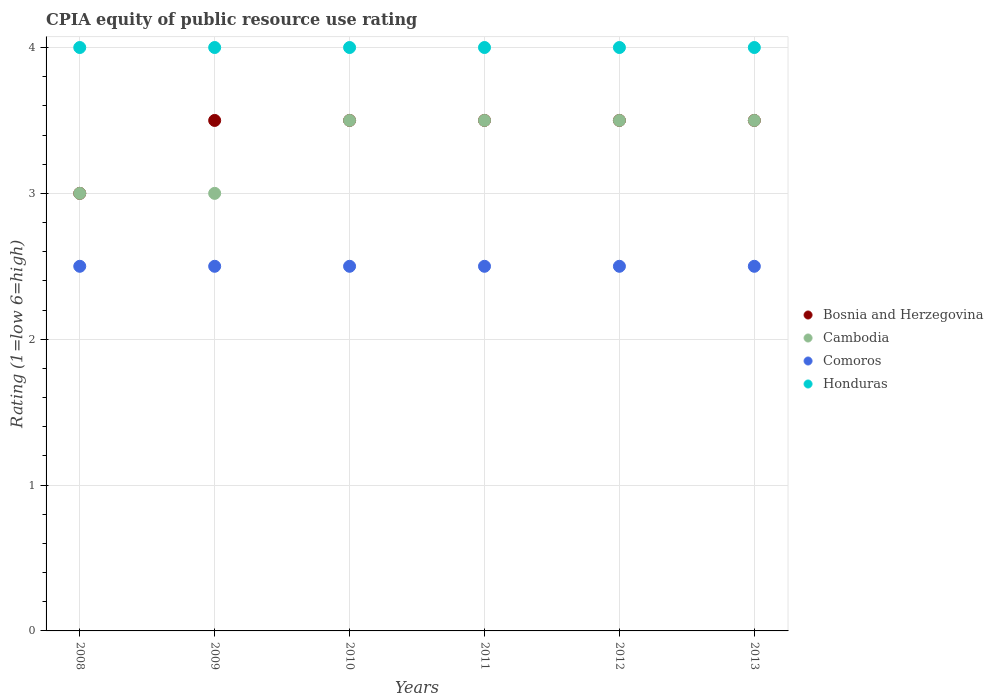Is the number of dotlines equal to the number of legend labels?
Your answer should be compact. Yes. What is the CPIA rating in Comoros in 2009?
Offer a terse response. 2.5. Across all years, what is the minimum CPIA rating in Cambodia?
Provide a succinct answer. 3. In which year was the CPIA rating in Comoros maximum?
Your answer should be compact. 2008. In which year was the CPIA rating in Bosnia and Herzegovina minimum?
Keep it short and to the point. 2008. What is the average CPIA rating in Bosnia and Herzegovina per year?
Give a very brief answer. 3.42. What is the ratio of the CPIA rating in Honduras in 2009 to that in 2013?
Provide a succinct answer. 1. Is the CPIA rating in Honduras in 2011 less than that in 2012?
Offer a terse response. No. Is the difference between the CPIA rating in Comoros in 2008 and 2009 greater than the difference between the CPIA rating in Cambodia in 2008 and 2009?
Your answer should be very brief. No. What is the difference between the highest and the second highest CPIA rating in Cambodia?
Provide a short and direct response. 0. In how many years, is the CPIA rating in Comoros greater than the average CPIA rating in Comoros taken over all years?
Give a very brief answer. 0. Is the sum of the CPIA rating in Cambodia in 2008 and 2011 greater than the maximum CPIA rating in Honduras across all years?
Provide a short and direct response. Yes. Is it the case that in every year, the sum of the CPIA rating in Bosnia and Herzegovina and CPIA rating in Comoros  is greater than the CPIA rating in Cambodia?
Make the answer very short. Yes. Is the CPIA rating in Bosnia and Herzegovina strictly greater than the CPIA rating in Comoros over the years?
Your answer should be very brief. Yes. How many years are there in the graph?
Keep it short and to the point. 6. Does the graph contain any zero values?
Offer a terse response. No. Does the graph contain grids?
Give a very brief answer. Yes. How many legend labels are there?
Ensure brevity in your answer.  4. How are the legend labels stacked?
Your answer should be very brief. Vertical. What is the title of the graph?
Ensure brevity in your answer.  CPIA equity of public resource use rating. What is the label or title of the X-axis?
Your answer should be very brief. Years. What is the label or title of the Y-axis?
Offer a very short reply. Rating (1=low 6=high). What is the Rating (1=low 6=high) in Bosnia and Herzegovina in 2008?
Provide a short and direct response. 3. What is the Rating (1=low 6=high) of Bosnia and Herzegovina in 2009?
Your response must be concise. 3.5. What is the Rating (1=low 6=high) in Cambodia in 2009?
Provide a short and direct response. 3. What is the Rating (1=low 6=high) in Comoros in 2009?
Your answer should be compact. 2.5. What is the Rating (1=low 6=high) in Honduras in 2009?
Your answer should be compact. 4. What is the Rating (1=low 6=high) in Bosnia and Herzegovina in 2010?
Provide a short and direct response. 3.5. What is the Rating (1=low 6=high) in Cambodia in 2010?
Keep it short and to the point. 3.5. What is the Rating (1=low 6=high) in Comoros in 2010?
Offer a very short reply. 2.5. What is the Rating (1=low 6=high) in Honduras in 2010?
Make the answer very short. 4. What is the Rating (1=low 6=high) of Bosnia and Herzegovina in 2011?
Provide a short and direct response. 3.5. What is the Rating (1=low 6=high) of Comoros in 2012?
Your answer should be very brief. 2.5. What is the Rating (1=low 6=high) of Cambodia in 2013?
Provide a short and direct response. 3.5. What is the Rating (1=low 6=high) of Comoros in 2013?
Keep it short and to the point. 2.5. What is the Rating (1=low 6=high) of Honduras in 2013?
Your answer should be compact. 4. Across all years, what is the maximum Rating (1=low 6=high) in Bosnia and Herzegovina?
Give a very brief answer. 3.5. Across all years, what is the maximum Rating (1=low 6=high) of Honduras?
Keep it short and to the point. 4. Across all years, what is the minimum Rating (1=low 6=high) in Bosnia and Herzegovina?
Offer a terse response. 3. Across all years, what is the minimum Rating (1=low 6=high) in Comoros?
Offer a very short reply. 2.5. Across all years, what is the minimum Rating (1=low 6=high) in Honduras?
Make the answer very short. 4. What is the total Rating (1=low 6=high) of Honduras in the graph?
Provide a short and direct response. 24. What is the difference between the Rating (1=low 6=high) in Bosnia and Herzegovina in 2008 and that in 2009?
Give a very brief answer. -0.5. What is the difference between the Rating (1=low 6=high) in Comoros in 2008 and that in 2009?
Keep it short and to the point. 0. What is the difference between the Rating (1=low 6=high) of Honduras in 2008 and that in 2009?
Your answer should be very brief. 0. What is the difference between the Rating (1=low 6=high) in Honduras in 2008 and that in 2010?
Your answer should be compact. 0. What is the difference between the Rating (1=low 6=high) in Honduras in 2008 and that in 2011?
Offer a very short reply. 0. What is the difference between the Rating (1=low 6=high) of Bosnia and Herzegovina in 2008 and that in 2012?
Your answer should be very brief. -0.5. What is the difference between the Rating (1=low 6=high) of Honduras in 2008 and that in 2012?
Your response must be concise. 0. What is the difference between the Rating (1=low 6=high) of Bosnia and Herzegovina in 2008 and that in 2013?
Give a very brief answer. -0.5. What is the difference between the Rating (1=low 6=high) in Cambodia in 2008 and that in 2013?
Provide a succinct answer. -0.5. What is the difference between the Rating (1=low 6=high) of Bosnia and Herzegovina in 2009 and that in 2010?
Keep it short and to the point. 0. What is the difference between the Rating (1=low 6=high) in Honduras in 2009 and that in 2010?
Offer a terse response. 0. What is the difference between the Rating (1=low 6=high) of Cambodia in 2009 and that in 2011?
Your answer should be very brief. -0.5. What is the difference between the Rating (1=low 6=high) in Bosnia and Herzegovina in 2009 and that in 2012?
Offer a terse response. 0. What is the difference between the Rating (1=low 6=high) in Bosnia and Herzegovina in 2009 and that in 2013?
Ensure brevity in your answer.  0. What is the difference between the Rating (1=low 6=high) in Cambodia in 2009 and that in 2013?
Provide a short and direct response. -0.5. What is the difference between the Rating (1=low 6=high) in Bosnia and Herzegovina in 2010 and that in 2011?
Give a very brief answer. 0. What is the difference between the Rating (1=low 6=high) of Honduras in 2010 and that in 2011?
Give a very brief answer. 0. What is the difference between the Rating (1=low 6=high) in Bosnia and Herzegovina in 2010 and that in 2012?
Offer a terse response. 0. What is the difference between the Rating (1=low 6=high) in Cambodia in 2010 and that in 2012?
Provide a short and direct response. 0. What is the difference between the Rating (1=low 6=high) of Bosnia and Herzegovina in 2010 and that in 2013?
Offer a terse response. 0. What is the difference between the Rating (1=low 6=high) in Comoros in 2010 and that in 2013?
Your response must be concise. 0. What is the difference between the Rating (1=low 6=high) of Honduras in 2010 and that in 2013?
Offer a terse response. 0. What is the difference between the Rating (1=low 6=high) of Bosnia and Herzegovina in 2011 and that in 2012?
Ensure brevity in your answer.  0. What is the difference between the Rating (1=low 6=high) in Honduras in 2011 and that in 2012?
Your answer should be compact. 0. What is the difference between the Rating (1=low 6=high) in Bosnia and Herzegovina in 2011 and that in 2013?
Your response must be concise. 0. What is the difference between the Rating (1=low 6=high) of Honduras in 2011 and that in 2013?
Give a very brief answer. 0. What is the difference between the Rating (1=low 6=high) of Comoros in 2012 and that in 2013?
Keep it short and to the point. 0. What is the difference between the Rating (1=low 6=high) of Bosnia and Herzegovina in 2008 and the Rating (1=low 6=high) of Cambodia in 2009?
Your response must be concise. 0. What is the difference between the Rating (1=low 6=high) of Bosnia and Herzegovina in 2008 and the Rating (1=low 6=high) of Comoros in 2009?
Your response must be concise. 0.5. What is the difference between the Rating (1=low 6=high) in Bosnia and Herzegovina in 2008 and the Rating (1=low 6=high) in Honduras in 2009?
Your response must be concise. -1. What is the difference between the Rating (1=low 6=high) in Comoros in 2008 and the Rating (1=low 6=high) in Honduras in 2009?
Offer a terse response. -1.5. What is the difference between the Rating (1=low 6=high) of Bosnia and Herzegovina in 2008 and the Rating (1=low 6=high) of Comoros in 2010?
Ensure brevity in your answer.  0.5. What is the difference between the Rating (1=low 6=high) of Bosnia and Herzegovina in 2008 and the Rating (1=low 6=high) of Honduras in 2010?
Ensure brevity in your answer.  -1. What is the difference between the Rating (1=low 6=high) in Cambodia in 2008 and the Rating (1=low 6=high) in Comoros in 2010?
Keep it short and to the point. 0.5. What is the difference between the Rating (1=low 6=high) in Cambodia in 2008 and the Rating (1=low 6=high) in Honduras in 2010?
Offer a very short reply. -1. What is the difference between the Rating (1=low 6=high) in Comoros in 2008 and the Rating (1=low 6=high) in Honduras in 2010?
Offer a terse response. -1.5. What is the difference between the Rating (1=low 6=high) in Bosnia and Herzegovina in 2008 and the Rating (1=low 6=high) in Honduras in 2011?
Your answer should be very brief. -1. What is the difference between the Rating (1=low 6=high) of Cambodia in 2008 and the Rating (1=low 6=high) of Honduras in 2011?
Your response must be concise. -1. What is the difference between the Rating (1=low 6=high) in Comoros in 2008 and the Rating (1=low 6=high) in Honduras in 2011?
Ensure brevity in your answer.  -1.5. What is the difference between the Rating (1=low 6=high) of Bosnia and Herzegovina in 2008 and the Rating (1=low 6=high) of Cambodia in 2012?
Your answer should be compact. -0.5. What is the difference between the Rating (1=low 6=high) of Cambodia in 2008 and the Rating (1=low 6=high) of Honduras in 2012?
Offer a very short reply. -1. What is the difference between the Rating (1=low 6=high) in Comoros in 2008 and the Rating (1=low 6=high) in Honduras in 2012?
Offer a very short reply. -1.5. What is the difference between the Rating (1=low 6=high) of Bosnia and Herzegovina in 2008 and the Rating (1=low 6=high) of Comoros in 2013?
Make the answer very short. 0.5. What is the difference between the Rating (1=low 6=high) in Bosnia and Herzegovina in 2008 and the Rating (1=low 6=high) in Honduras in 2013?
Give a very brief answer. -1. What is the difference between the Rating (1=low 6=high) in Cambodia in 2008 and the Rating (1=low 6=high) in Honduras in 2013?
Your response must be concise. -1. What is the difference between the Rating (1=low 6=high) in Bosnia and Herzegovina in 2009 and the Rating (1=low 6=high) in Cambodia in 2010?
Your answer should be very brief. 0. What is the difference between the Rating (1=low 6=high) in Bosnia and Herzegovina in 2009 and the Rating (1=low 6=high) in Honduras in 2010?
Give a very brief answer. -0.5. What is the difference between the Rating (1=low 6=high) in Cambodia in 2009 and the Rating (1=low 6=high) in Comoros in 2010?
Offer a terse response. 0.5. What is the difference between the Rating (1=low 6=high) in Cambodia in 2009 and the Rating (1=low 6=high) in Honduras in 2010?
Ensure brevity in your answer.  -1. What is the difference between the Rating (1=low 6=high) in Comoros in 2009 and the Rating (1=low 6=high) in Honduras in 2010?
Give a very brief answer. -1.5. What is the difference between the Rating (1=low 6=high) in Bosnia and Herzegovina in 2009 and the Rating (1=low 6=high) in Cambodia in 2012?
Your response must be concise. 0. What is the difference between the Rating (1=low 6=high) in Bosnia and Herzegovina in 2009 and the Rating (1=low 6=high) in Honduras in 2012?
Your response must be concise. -0.5. What is the difference between the Rating (1=low 6=high) of Cambodia in 2009 and the Rating (1=low 6=high) of Honduras in 2012?
Your response must be concise. -1. What is the difference between the Rating (1=low 6=high) of Cambodia in 2009 and the Rating (1=low 6=high) of Honduras in 2013?
Provide a short and direct response. -1. What is the difference between the Rating (1=low 6=high) of Comoros in 2009 and the Rating (1=low 6=high) of Honduras in 2013?
Offer a terse response. -1.5. What is the difference between the Rating (1=low 6=high) in Cambodia in 2010 and the Rating (1=low 6=high) in Comoros in 2011?
Your response must be concise. 1. What is the difference between the Rating (1=low 6=high) in Cambodia in 2010 and the Rating (1=low 6=high) in Honduras in 2011?
Give a very brief answer. -0.5. What is the difference between the Rating (1=low 6=high) of Bosnia and Herzegovina in 2010 and the Rating (1=low 6=high) of Cambodia in 2012?
Provide a short and direct response. 0. What is the difference between the Rating (1=low 6=high) in Bosnia and Herzegovina in 2010 and the Rating (1=low 6=high) in Comoros in 2012?
Ensure brevity in your answer.  1. What is the difference between the Rating (1=low 6=high) in Cambodia in 2010 and the Rating (1=low 6=high) in Comoros in 2012?
Keep it short and to the point. 1. What is the difference between the Rating (1=low 6=high) of Comoros in 2010 and the Rating (1=low 6=high) of Honduras in 2012?
Keep it short and to the point. -1.5. What is the difference between the Rating (1=low 6=high) of Bosnia and Herzegovina in 2010 and the Rating (1=low 6=high) of Comoros in 2013?
Keep it short and to the point. 1. What is the difference between the Rating (1=low 6=high) of Bosnia and Herzegovina in 2010 and the Rating (1=low 6=high) of Honduras in 2013?
Provide a succinct answer. -0.5. What is the difference between the Rating (1=low 6=high) of Cambodia in 2011 and the Rating (1=low 6=high) of Comoros in 2012?
Your response must be concise. 1. What is the difference between the Rating (1=low 6=high) of Cambodia in 2011 and the Rating (1=low 6=high) of Honduras in 2012?
Your answer should be compact. -0.5. What is the difference between the Rating (1=low 6=high) of Bosnia and Herzegovina in 2011 and the Rating (1=low 6=high) of Cambodia in 2013?
Give a very brief answer. 0. What is the difference between the Rating (1=low 6=high) in Bosnia and Herzegovina in 2011 and the Rating (1=low 6=high) in Comoros in 2013?
Make the answer very short. 1. What is the difference between the Rating (1=low 6=high) of Bosnia and Herzegovina in 2011 and the Rating (1=low 6=high) of Honduras in 2013?
Make the answer very short. -0.5. What is the difference between the Rating (1=low 6=high) in Bosnia and Herzegovina in 2012 and the Rating (1=low 6=high) in Comoros in 2013?
Keep it short and to the point. 1. What is the difference between the Rating (1=low 6=high) in Cambodia in 2012 and the Rating (1=low 6=high) in Honduras in 2013?
Ensure brevity in your answer.  -0.5. What is the average Rating (1=low 6=high) in Bosnia and Herzegovina per year?
Ensure brevity in your answer.  3.42. What is the average Rating (1=low 6=high) in Comoros per year?
Provide a succinct answer. 2.5. What is the average Rating (1=low 6=high) in Honduras per year?
Your answer should be compact. 4. In the year 2008, what is the difference between the Rating (1=low 6=high) of Bosnia and Herzegovina and Rating (1=low 6=high) of Honduras?
Provide a short and direct response. -1. In the year 2008, what is the difference between the Rating (1=low 6=high) of Cambodia and Rating (1=low 6=high) of Comoros?
Keep it short and to the point. 0.5. In the year 2008, what is the difference between the Rating (1=low 6=high) of Cambodia and Rating (1=low 6=high) of Honduras?
Make the answer very short. -1. In the year 2008, what is the difference between the Rating (1=low 6=high) in Comoros and Rating (1=low 6=high) in Honduras?
Offer a terse response. -1.5. In the year 2009, what is the difference between the Rating (1=low 6=high) in Bosnia and Herzegovina and Rating (1=low 6=high) in Cambodia?
Make the answer very short. 0.5. In the year 2009, what is the difference between the Rating (1=low 6=high) of Bosnia and Herzegovina and Rating (1=low 6=high) of Comoros?
Your response must be concise. 1. In the year 2009, what is the difference between the Rating (1=low 6=high) of Cambodia and Rating (1=low 6=high) of Comoros?
Offer a terse response. 0.5. In the year 2009, what is the difference between the Rating (1=low 6=high) in Cambodia and Rating (1=low 6=high) in Honduras?
Ensure brevity in your answer.  -1. In the year 2010, what is the difference between the Rating (1=low 6=high) in Bosnia and Herzegovina and Rating (1=low 6=high) in Comoros?
Make the answer very short. 1. In the year 2010, what is the difference between the Rating (1=low 6=high) of Cambodia and Rating (1=low 6=high) of Honduras?
Ensure brevity in your answer.  -0.5. In the year 2010, what is the difference between the Rating (1=low 6=high) in Comoros and Rating (1=low 6=high) in Honduras?
Offer a very short reply. -1.5. In the year 2011, what is the difference between the Rating (1=low 6=high) in Bosnia and Herzegovina and Rating (1=low 6=high) in Cambodia?
Ensure brevity in your answer.  0. In the year 2011, what is the difference between the Rating (1=low 6=high) in Cambodia and Rating (1=low 6=high) in Comoros?
Your answer should be compact. 1. In the year 2011, what is the difference between the Rating (1=low 6=high) of Comoros and Rating (1=low 6=high) of Honduras?
Provide a succinct answer. -1.5. In the year 2012, what is the difference between the Rating (1=low 6=high) in Bosnia and Herzegovina and Rating (1=low 6=high) in Comoros?
Offer a very short reply. 1. In the year 2012, what is the difference between the Rating (1=low 6=high) of Bosnia and Herzegovina and Rating (1=low 6=high) of Honduras?
Your answer should be very brief. -0.5. In the year 2012, what is the difference between the Rating (1=low 6=high) in Cambodia and Rating (1=low 6=high) in Comoros?
Your answer should be very brief. 1. In the year 2013, what is the difference between the Rating (1=low 6=high) in Bosnia and Herzegovina and Rating (1=low 6=high) in Cambodia?
Offer a terse response. 0. In the year 2013, what is the difference between the Rating (1=low 6=high) of Cambodia and Rating (1=low 6=high) of Comoros?
Your response must be concise. 1. In the year 2013, what is the difference between the Rating (1=low 6=high) of Cambodia and Rating (1=low 6=high) of Honduras?
Give a very brief answer. -0.5. What is the ratio of the Rating (1=low 6=high) of Bosnia and Herzegovina in 2008 to that in 2009?
Give a very brief answer. 0.86. What is the ratio of the Rating (1=low 6=high) in Cambodia in 2008 to that in 2009?
Your answer should be compact. 1. What is the ratio of the Rating (1=low 6=high) of Comoros in 2008 to that in 2009?
Offer a very short reply. 1. What is the ratio of the Rating (1=low 6=high) of Comoros in 2008 to that in 2010?
Give a very brief answer. 1. What is the ratio of the Rating (1=low 6=high) in Comoros in 2008 to that in 2011?
Ensure brevity in your answer.  1. What is the ratio of the Rating (1=low 6=high) in Cambodia in 2008 to that in 2012?
Your answer should be very brief. 0.86. What is the ratio of the Rating (1=low 6=high) in Comoros in 2008 to that in 2012?
Your answer should be compact. 1. What is the ratio of the Rating (1=low 6=high) of Honduras in 2008 to that in 2012?
Ensure brevity in your answer.  1. What is the ratio of the Rating (1=low 6=high) of Cambodia in 2008 to that in 2013?
Offer a very short reply. 0.86. What is the ratio of the Rating (1=low 6=high) in Comoros in 2008 to that in 2013?
Your answer should be very brief. 1. What is the ratio of the Rating (1=low 6=high) in Comoros in 2009 to that in 2010?
Offer a terse response. 1. What is the ratio of the Rating (1=low 6=high) of Bosnia and Herzegovina in 2009 to that in 2011?
Give a very brief answer. 1. What is the ratio of the Rating (1=low 6=high) in Cambodia in 2009 to that in 2011?
Give a very brief answer. 0.86. What is the ratio of the Rating (1=low 6=high) of Comoros in 2009 to that in 2011?
Provide a succinct answer. 1. What is the ratio of the Rating (1=low 6=high) of Honduras in 2009 to that in 2011?
Provide a short and direct response. 1. What is the ratio of the Rating (1=low 6=high) of Cambodia in 2009 to that in 2012?
Your answer should be compact. 0.86. What is the ratio of the Rating (1=low 6=high) in Honduras in 2009 to that in 2013?
Make the answer very short. 1. What is the ratio of the Rating (1=low 6=high) of Bosnia and Herzegovina in 2010 to that in 2011?
Offer a terse response. 1. What is the ratio of the Rating (1=low 6=high) of Cambodia in 2010 to that in 2011?
Your response must be concise. 1. What is the ratio of the Rating (1=low 6=high) of Comoros in 2010 to that in 2011?
Keep it short and to the point. 1. What is the ratio of the Rating (1=low 6=high) of Honduras in 2010 to that in 2011?
Your response must be concise. 1. What is the ratio of the Rating (1=low 6=high) of Bosnia and Herzegovina in 2010 to that in 2012?
Offer a very short reply. 1. What is the ratio of the Rating (1=low 6=high) of Cambodia in 2010 to that in 2012?
Offer a very short reply. 1. What is the ratio of the Rating (1=low 6=high) in Comoros in 2010 to that in 2012?
Provide a succinct answer. 1. What is the ratio of the Rating (1=low 6=high) in Honduras in 2010 to that in 2012?
Ensure brevity in your answer.  1. What is the ratio of the Rating (1=low 6=high) in Honduras in 2010 to that in 2013?
Keep it short and to the point. 1. What is the ratio of the Rating (1=low 6=high) of Bosnia and Herzegovina in 2011 to that in 2012?
Provide a succinct answer. 1. What is the ratio of the Rating (1=low 6=high) of Cambodia in 2011 to that in 2012?
Your answer should be compact. 1. What is the ratio of the Rating (1=low 6=high) of Honduras in 2011 to that in 2012?
Make the answer very short. 1. What is the ratio of the Rating (1=low 6=high) of Bosnia and Herzegovina in 2011 to that in 2013?
Keep it short and to the point. 1. What is the ratio of the Rating (1=low 6=high) in Honduras in 2011 to that in 2013?
Provide a succinct answer. 1. What is the ratio of the Rating (1=low 6=high) of Bosnia and Herzegovina in 2012 to that in 2013?
Offer a terse response. 1. What is the ratio of the Rating (1=low 6=high) of Comoros in 2012 to that in 2013?
Your answer should be very brief. 1. What is the difference between the highest and the second highest Rating (1=low 6=high) in Comoros?
Ensure brevity in your answer.  0. What is the difference between the highest and the lowest Rating (1=low 6=high) in Bosnia and Herzegovina?
Provide a short and direct response. 0.5. What is the difference between the highest and the lowest Rating (1=low 6=high) of Cambodia?
Your answer should be very brief. 0.5. What is the difference between the highest and the lowest Rating (1=low 6=high) of Comoros?
Give a very brief answer. 0. 